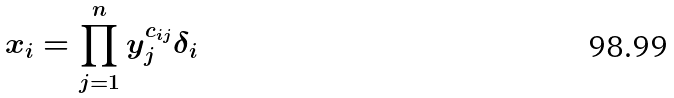<formula> <loc_0><loc_0><loc_500><loc_500>x _ { i } = \prod _ { j = 1 } ^ { n } y _ { j } ^ { c _ { i j } } \delta _ { i }</formula> 